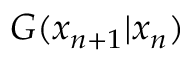Convert formula to latex. <formula><loc_0><loc_0><loc_500><loc_500>G ( x _ { n + 1 } | x _ { n } )</formula> 